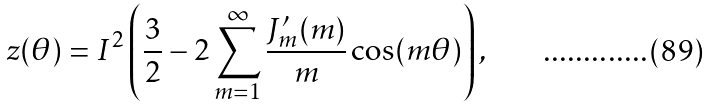Convert formula to latex. <formula><loc_0><loc_0><loc_500><loc_500>z ( \theta ) = I ^ { 2 } \left ( \frac { 3 } { 2 } - 2 \sum _ { m = 1 } ^ { \infty } { \frac { J ^ { \prime } _ { m } ( m ) } { m } \cos ( m \theta ) } \right ) ,</formula> 